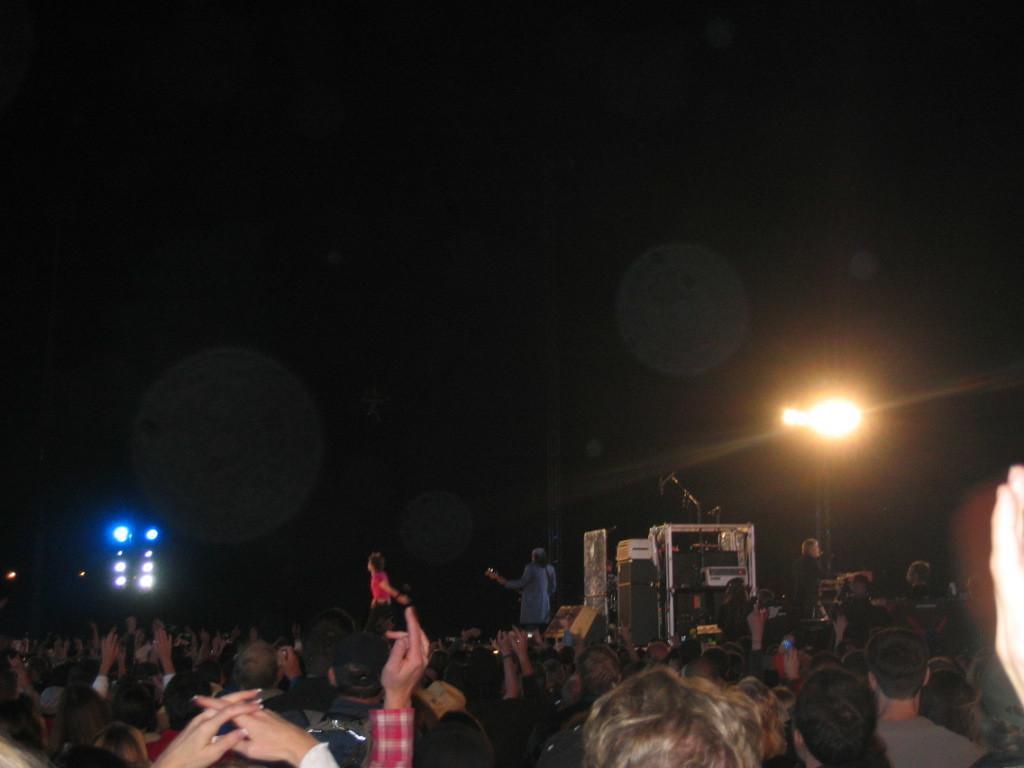Describe this image in one or two sentences. In this image there are so many people. On the left side, we can see blue color lights. On the right side, we can see big light. The sky is dark. 